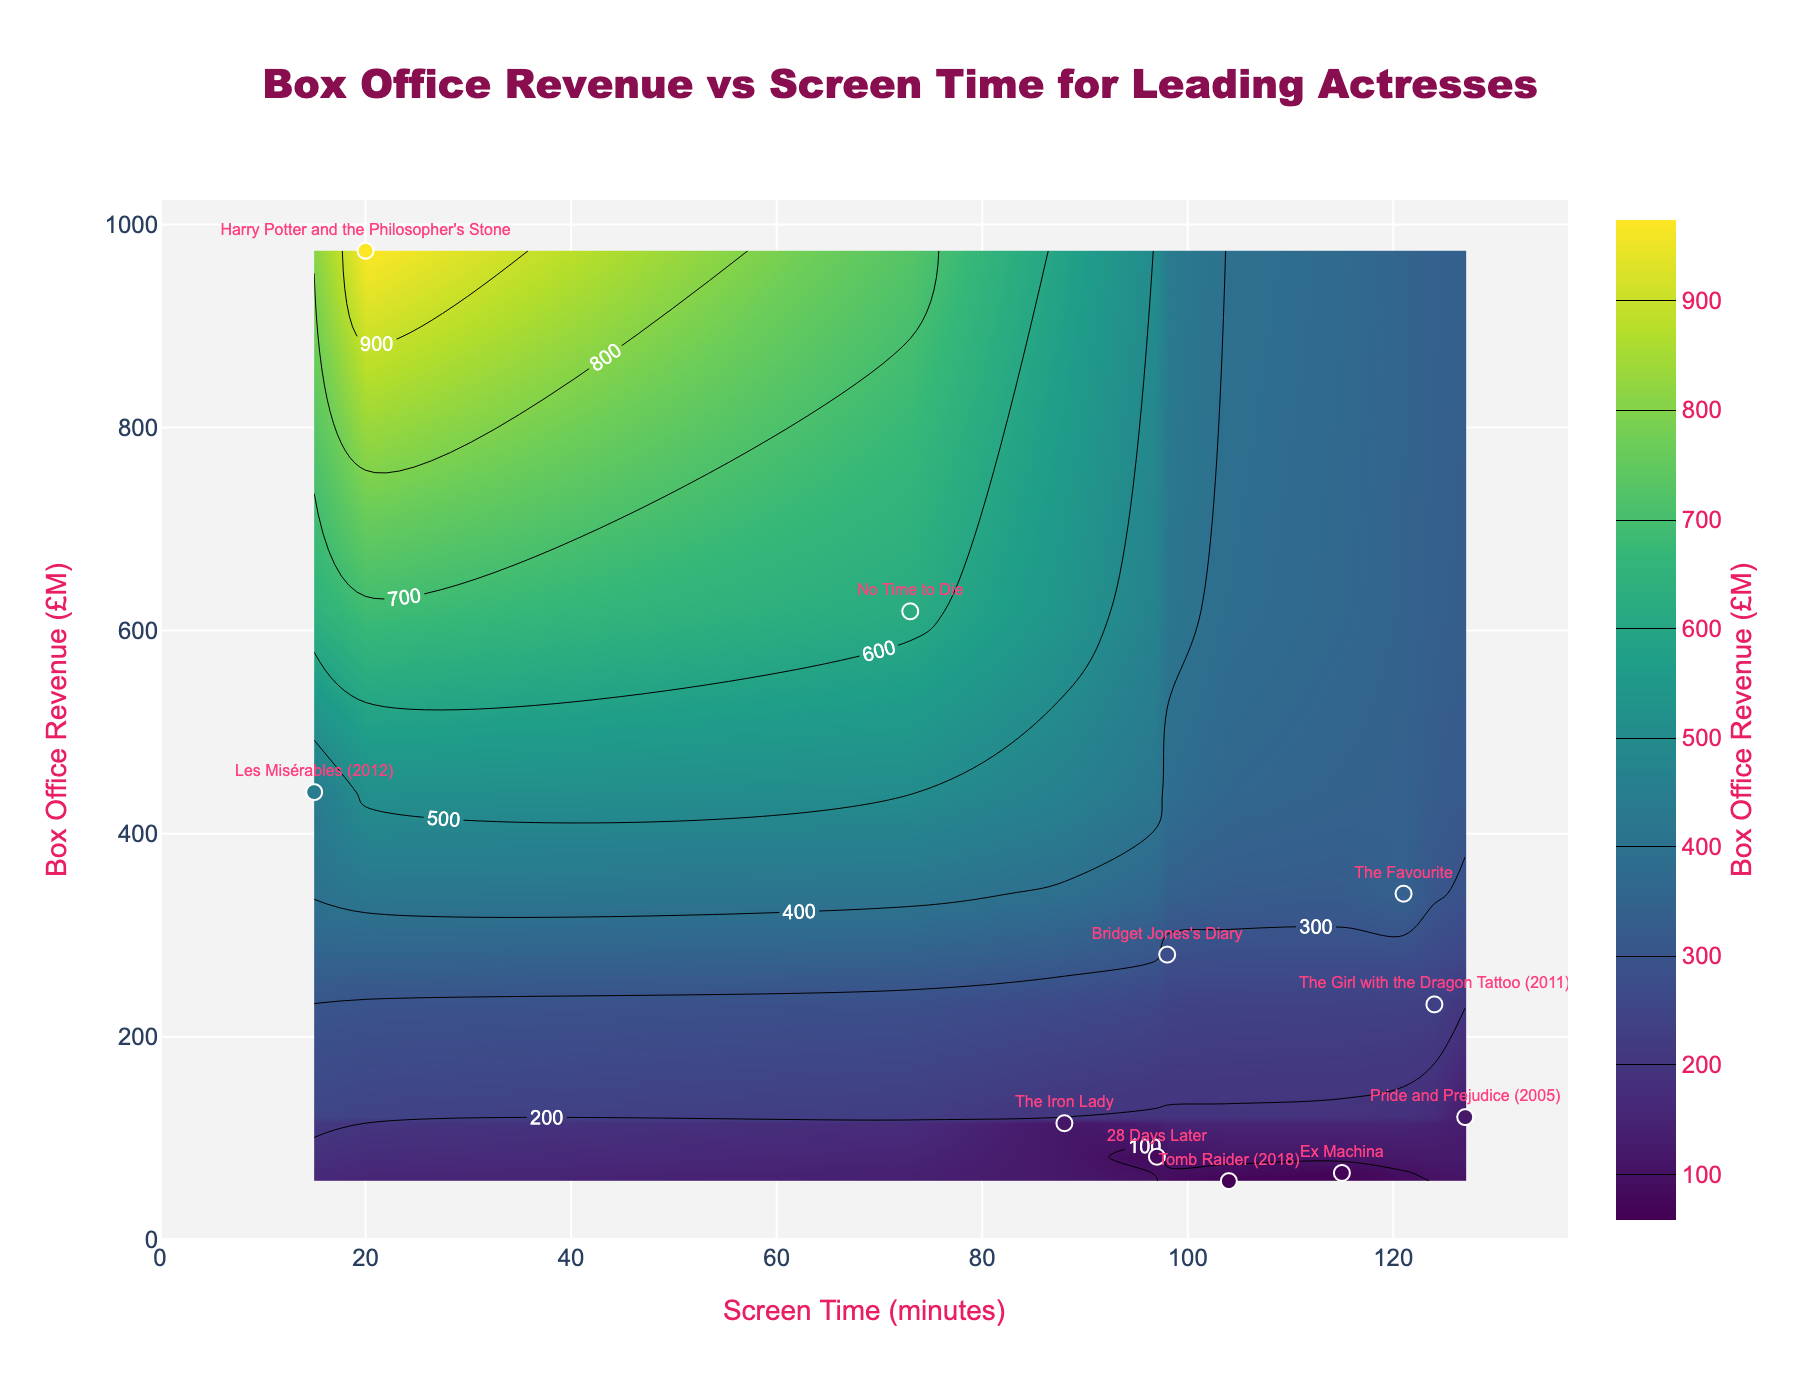How many genres are represented in the plot? Count the unique genres in the scatter plot labels.
Answer: 11 Which film has the highest box office revenue, and what is the value? Identify the film at the highest point on the y-axis which represents the box office revenue.
Answer: "Harry Potter and the Philosopher's Stone" with £974M Which film has the lowest screen time, and what is the value? Find the film at the lowest point on the x-axis which represents the screen time.
Answer: "Les Misérables (2012)" with 15 minutes Compare the box office revenues of "No Time to Die" and "The Girl with the Dragon Tattoo (2011)". Which one is higher? Identify the box office revenues for both films on the y-axis and compare them.
Answer: "No Time to Die" is higher with £619M What is the sum of the box office revenues for "Ex Machina" and "Pride and Prejudice (2005)"? Find the box office revenues for both films and add them together.
Answer: £66M + £121M = £187M Which genre has a leading actress with the longest screen time, and how long is it? Identify the film with the maximum screen time on the x-axis and note its genre.
Answer: Romantic Drama, 127 minutes Is there any film with a box office revenue higher than £500M but with less than 80 minutes of screen time? If so, name it. Investigate the region on the plot with box office values higher than £500M and screen times less than 80 minutes.
Answer: Yes, "No Time to Die" What is the average screen time of the leading actresses in the plot? Sum the screen times of all films and divide by the number of films.
Answer: (98+121+73+20+97+115+15+104+127+88+124)/11 ≈ 88.82 minutes Which film in the action genre has the highest box office revenue, and what is its value? Identify the films categorized under the action genre and find the one with the highest y-axis value.
Answer: "No Time to Die" with £619M What is the difference in box office revenue between "The Favourite" and "The Iron Lady"? Subtract the box office revenue of "The Iron Lady" from that of "The Favourite".
Answer: £341M - £115M = £226M 